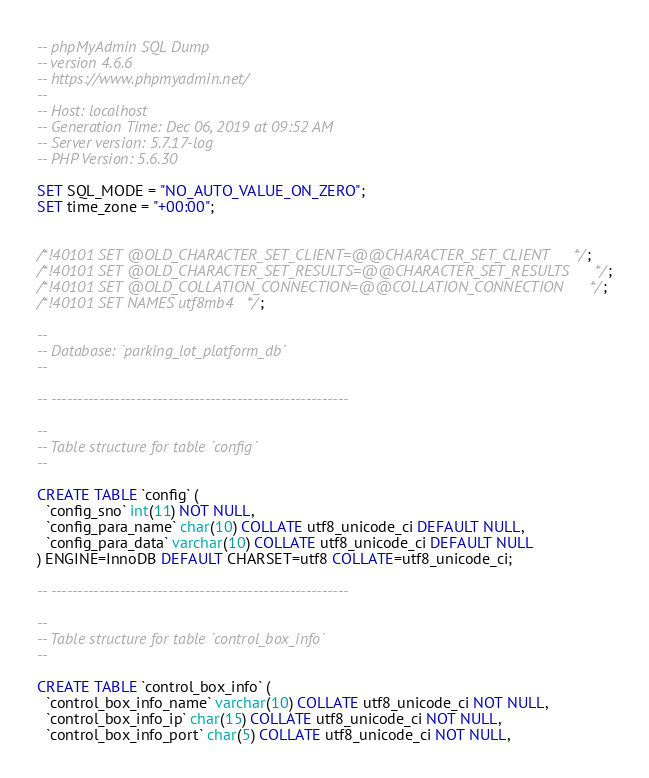<code> <loc_0><loc_0><loc_500><loc_500><_SQL_>-- phpMyAdmin SQL Dump
-- version 4.6.6
-- https://www.phpmyadmin.net/
--
-- Host: localhost
-- Generation Time: Dec 06, 2019 at 09:52 AM
-- Server version: 5.7.17-log
-- PHP Version: 5.6.30

SET SQL_MODE = "NO_AUTO_VALUE_ON_ZERO";
SET time_zone = "+00:00";


/*!40101 SET @OLD_CHARACTER_SET_CLIENT=@@CHARACTER_SET_CLIENT */;
/*!40101 SET @OLD_CHARACTER_SET_RESULTS=@@CHARACTER_SET_RESULTS */;
/*!40101 SET @OLD_COLLATION_CONNECTION=@@COLLATION_CONNECTION */;
/*!40101 SET NAMES utf8mb4 */;

--
-- Database: `parking_lot_platform_db`
--

-- --------------------------------------------------------

--
-- Table structure for table `config`
--

CREATE TABLE `config` (
  `config_sno` int(11) NOT NULL,
  `config_para_name` char(10) COLLATE utf8_unicode_ci DEFAULT NULL,
  `config_para_data` varchar(10) COLLATE utf8_unicode_ci DEFAULT NULL
) ENGINE=InnoDB DEFAULT CHARSET=utf8 COLLATE=utf8_unicode_ci;

-- --------------------------------------------------------

--
-- Table structure for table `control_box_info`
--

CREATE TABLE `control_box_info` (
  `control_box_info_name` varchar(10) COLLATE utf8_unicode_ci NOT NULL,
  `control_box_info_ip` char(15) COLLATE utf8_unicode_ci NOT NULL,
  `control_box_info_port` char(5) COLLATE utf8_unicode_ci NOT NULL,</code> 